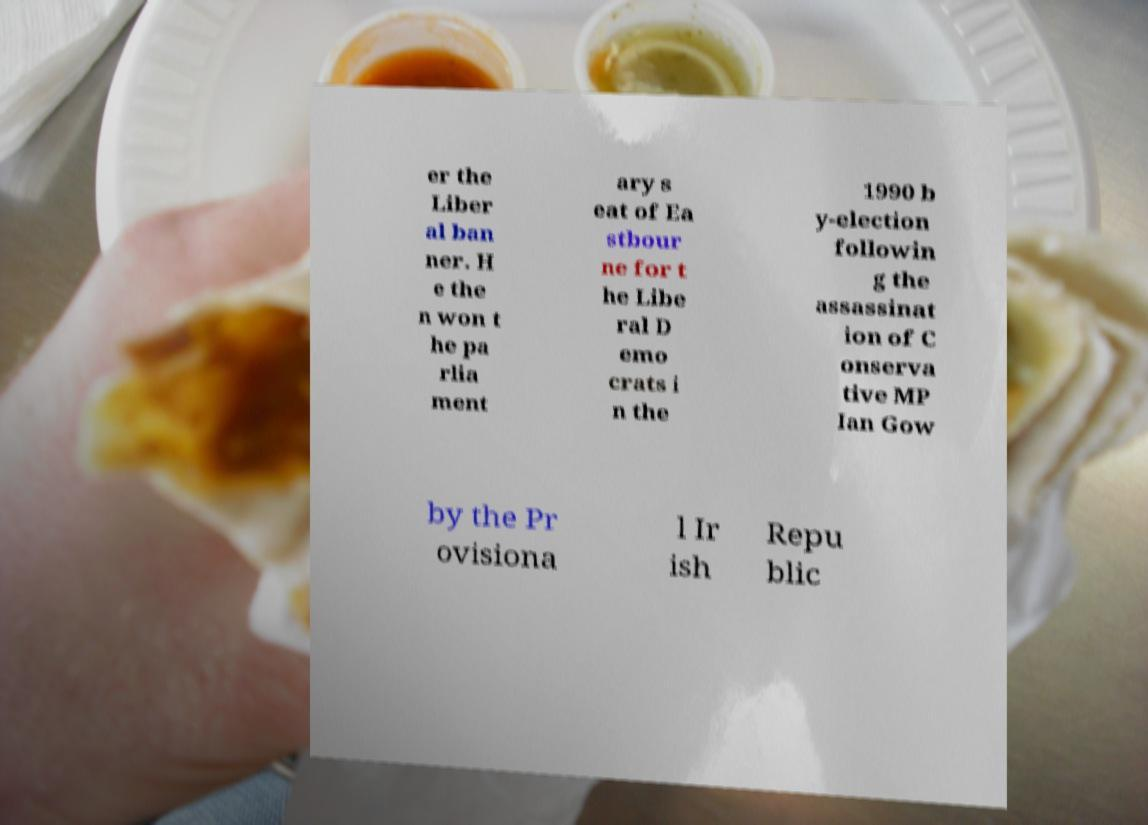Can you accurately transcribe the text from the provided image for me? er the Liber al ban ner. H e the n won t he pa rlia ment ary s eat of Ea stbour ne for t he Libe ral D emo crats i n the 1990 b y-election followin g the assassinat ion of C onserva tive MP Ian Gow by the Pr ovisiona l Ir ish Repu blic 